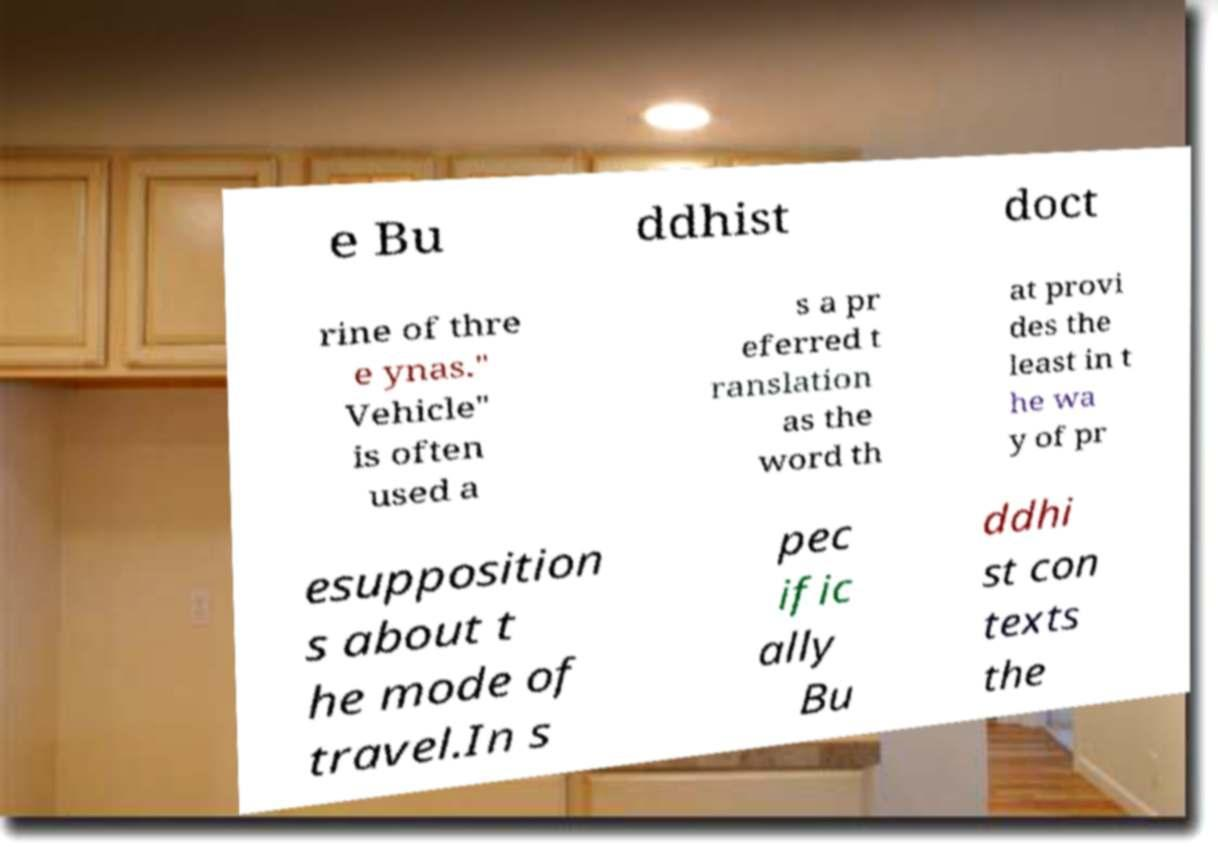Can you read and provide the text displayed in the image?This photo seems to have some interesting text. Can you extract and type it out for me? e Bu ddhist doct rine of thre e ynas." Vehicle" is often used a s a pr eferred t ranslation as the word th at provi des the least in t he wa y of pr esupposition s about t he mode of travel.In s pec ific ally Bu ddhi st con texts the 